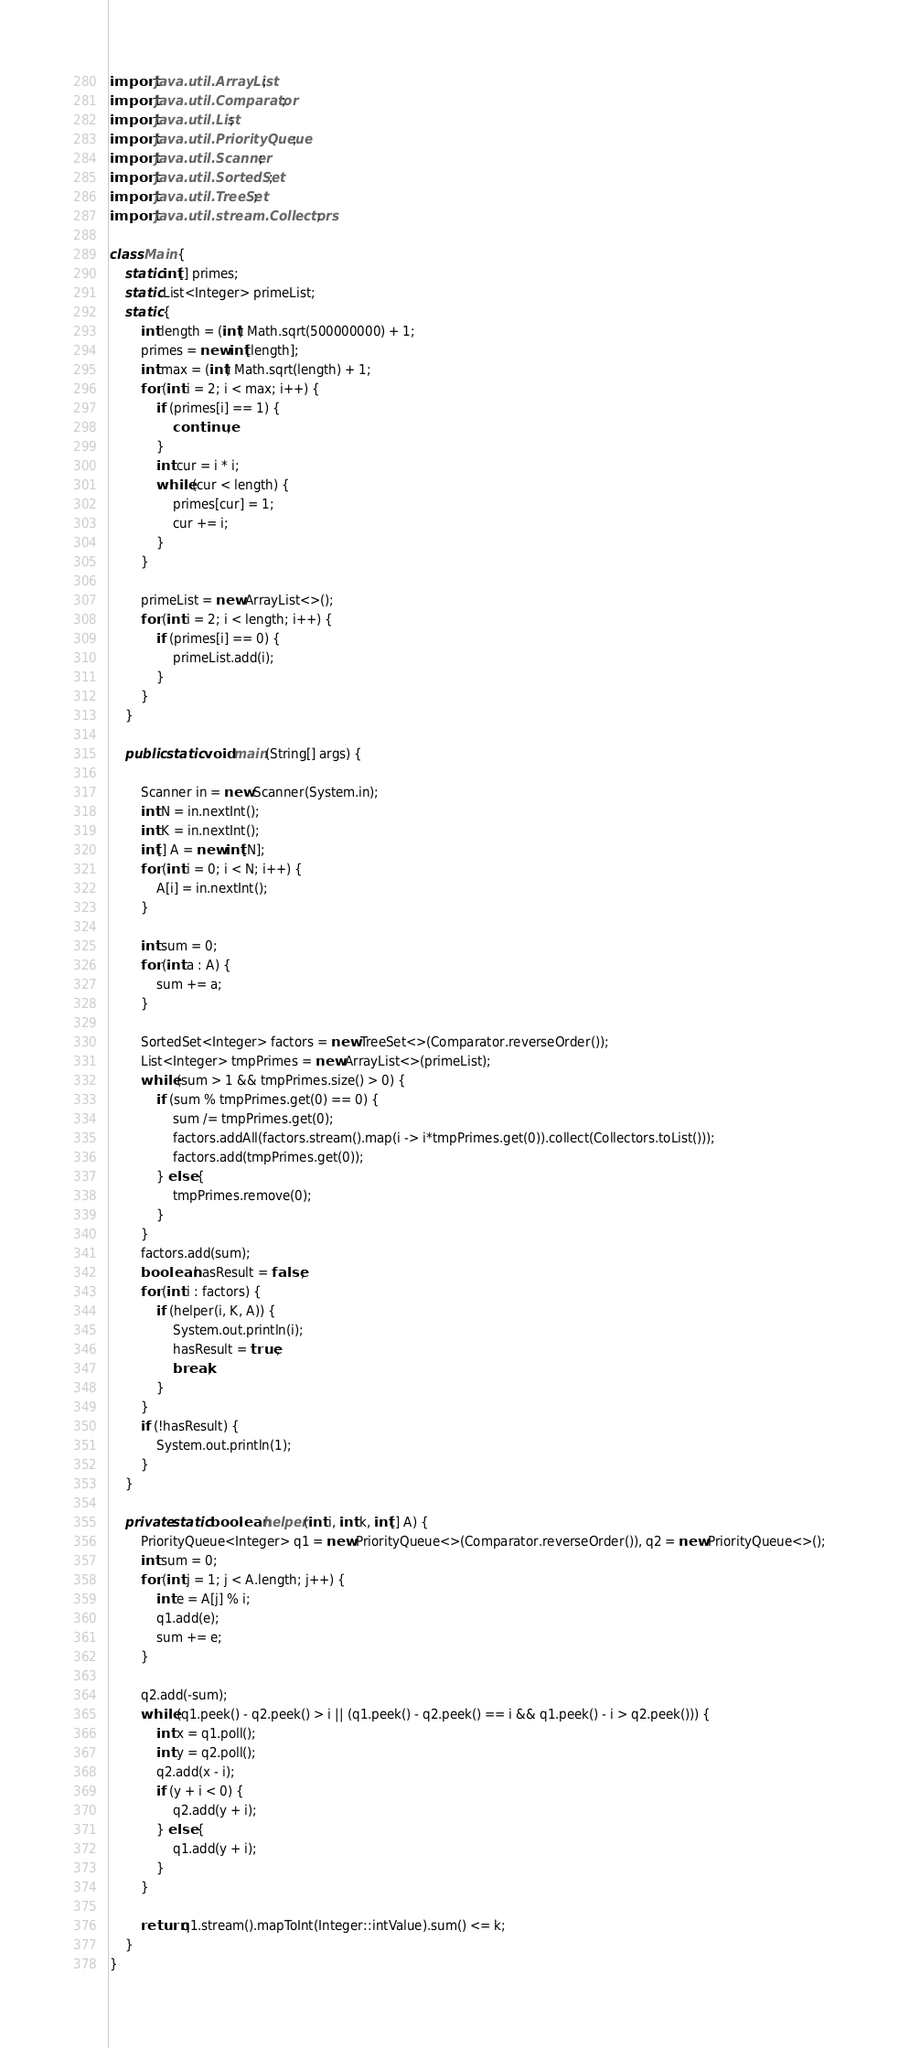Convert code to text. <code><loc_0><loc_0><loc_500><loc_500><_Java_>import java.util.ArrayList;
import java.util.Comparator;
import java.util.List;
import java.util.PriorityQueue;
import java.util.Scanner;
import java.util.SortedSet;
import java.util.TreeSet;
import java.util.stream.Collectors;

class Main {
    static int[] primes;
    static List<Integer> primeList;
    static {
        int length = (int) Math.sqrt(500000000) + 1;
        primes = new int[length];
        int max = (int) Math.sqrt(length) + 1;
        for (int i = 2; i < max; i++) {
            if (primes[i] == 1) {
                continue;
            }
            int cur = i * i;
            while (cur < length) {
                primes[cur] = 1;
                cur += i;
            }
        }

        primeList = new ArrayList<>();
        for (int i = 2; i < length; i++) {
            if (primes[i] == 0) {
                primeList.add(i);
            }
        }
    }

    public static void main(String[] args) {

        Scanner in = new Scanner(System.in);
        int N = in.nextInt();
        int K = in.nextInt();
        int[] A = new int[N];
        for (int i = 0; i < N; i++) {
            A[i] = in.nextInt();
        }

        int sum = 0;
        for (int a : A) {
            sum += a;
        }

        SortedSet<Integer> factors = new TreeSet<>(Comparator.reverseOrder());
        List<Integer> tmpPrimes = new ArrayList<>(primeList);
        while (sum > 1 && tmpPrimes.size() > 0) {
            if (sum % tmpPrimes.get(0) == 0) {
                sum /= tmpPrimes.get(0);
                factors.addAll(factors.stream().map(i -> i*tmpPrimes.get(0)).collect(Collectors.toList()));
                factors.add(tmpPrimes.get(0));
            } else {
                tmpPrimes.remove(0);
            }
        }
        factors.add(sum);
        boolean hasResult = false;
        for (int i : factors) {
            if (helper(i, K, A)) {
                System.out.println(i);
                hasResult = true;
                break;
            }
        }
        if (!hasResult) {
            System.out.println(1);
        }
    }

    private static boolean helper(int i, int k, int[] A) {
        PriorityQueue<Integer> q1 = new PriorityQueue<>(Comparator.reverseOrder()), q2 = new PriorityQueue<>();
        int sum = 0;
        for (int j = 1; j < A.length; j++) {
            int e = A[j] % i;
            q1.add(e);
            sum += e;
        }

        q2.add(-sum);
        while (q1.peek() - q2.peek() > i || (q1.peek() - q2.peek() == i && q1.peek() - i > q2.peek())) {
            int x = q1.poll();
            int y = q2.poll();
            q2.add(x - i);
            if (y + i < 0) {
                q2.add(y + i);
            } else {
                q1.add(y + i);
            }
        }
        
        return q1.stream().mapToInt(Integer::intValue).sum() <= k;
    }
}</code> 